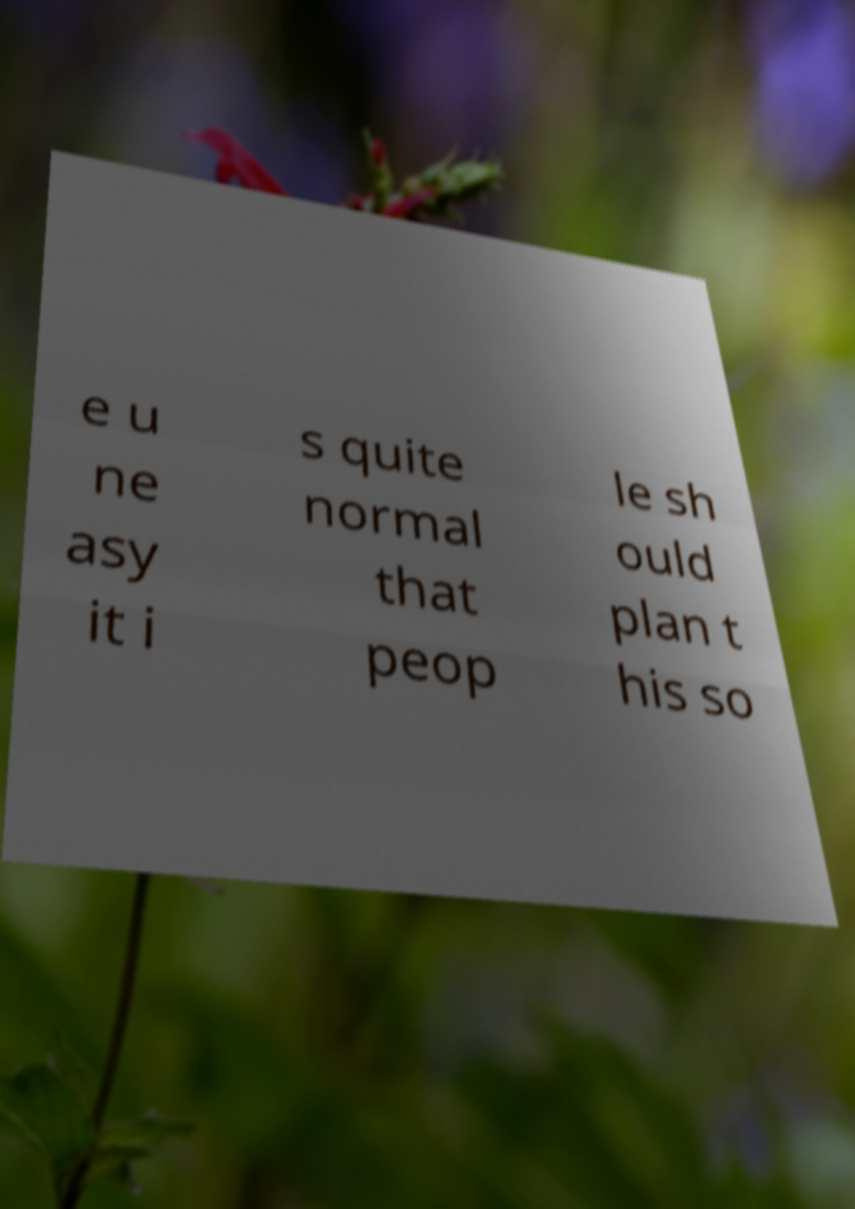Can you read and provide the text displayed in the image?This photo seems to have some interesting text. Can you extract and type it out for me? e u ne asy it i s quite normal that peop le sh ould plan t his so 